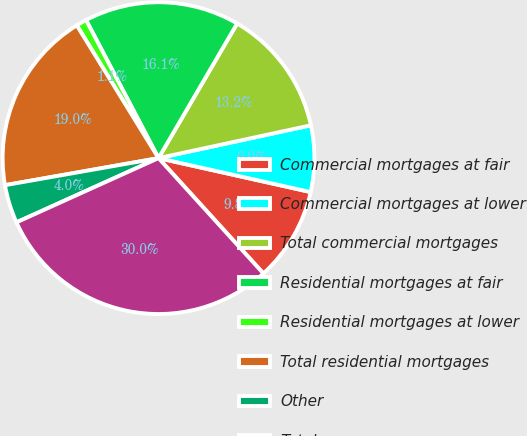Convert chart. <chart><loc_0><loc_0><loc_500><loc_500><pie_chart><fcel>Commercial mortgages at fair<fcel>Commercial mortgages at lower<fcel>Total commercial mortgages<fcel>Residential mortgages at fair<fcel>Residential mortgages at lower<fcel>Total residential mortgages<fcel>Other<fcel>Total<nl><fcel>9.76%<fcel>6.87%<fcel>13.21%<fcel>16.1%<fcel>1.09%<fcel>18.99%<fcel>3.98%<fcel>29.98%<nl></chart> 